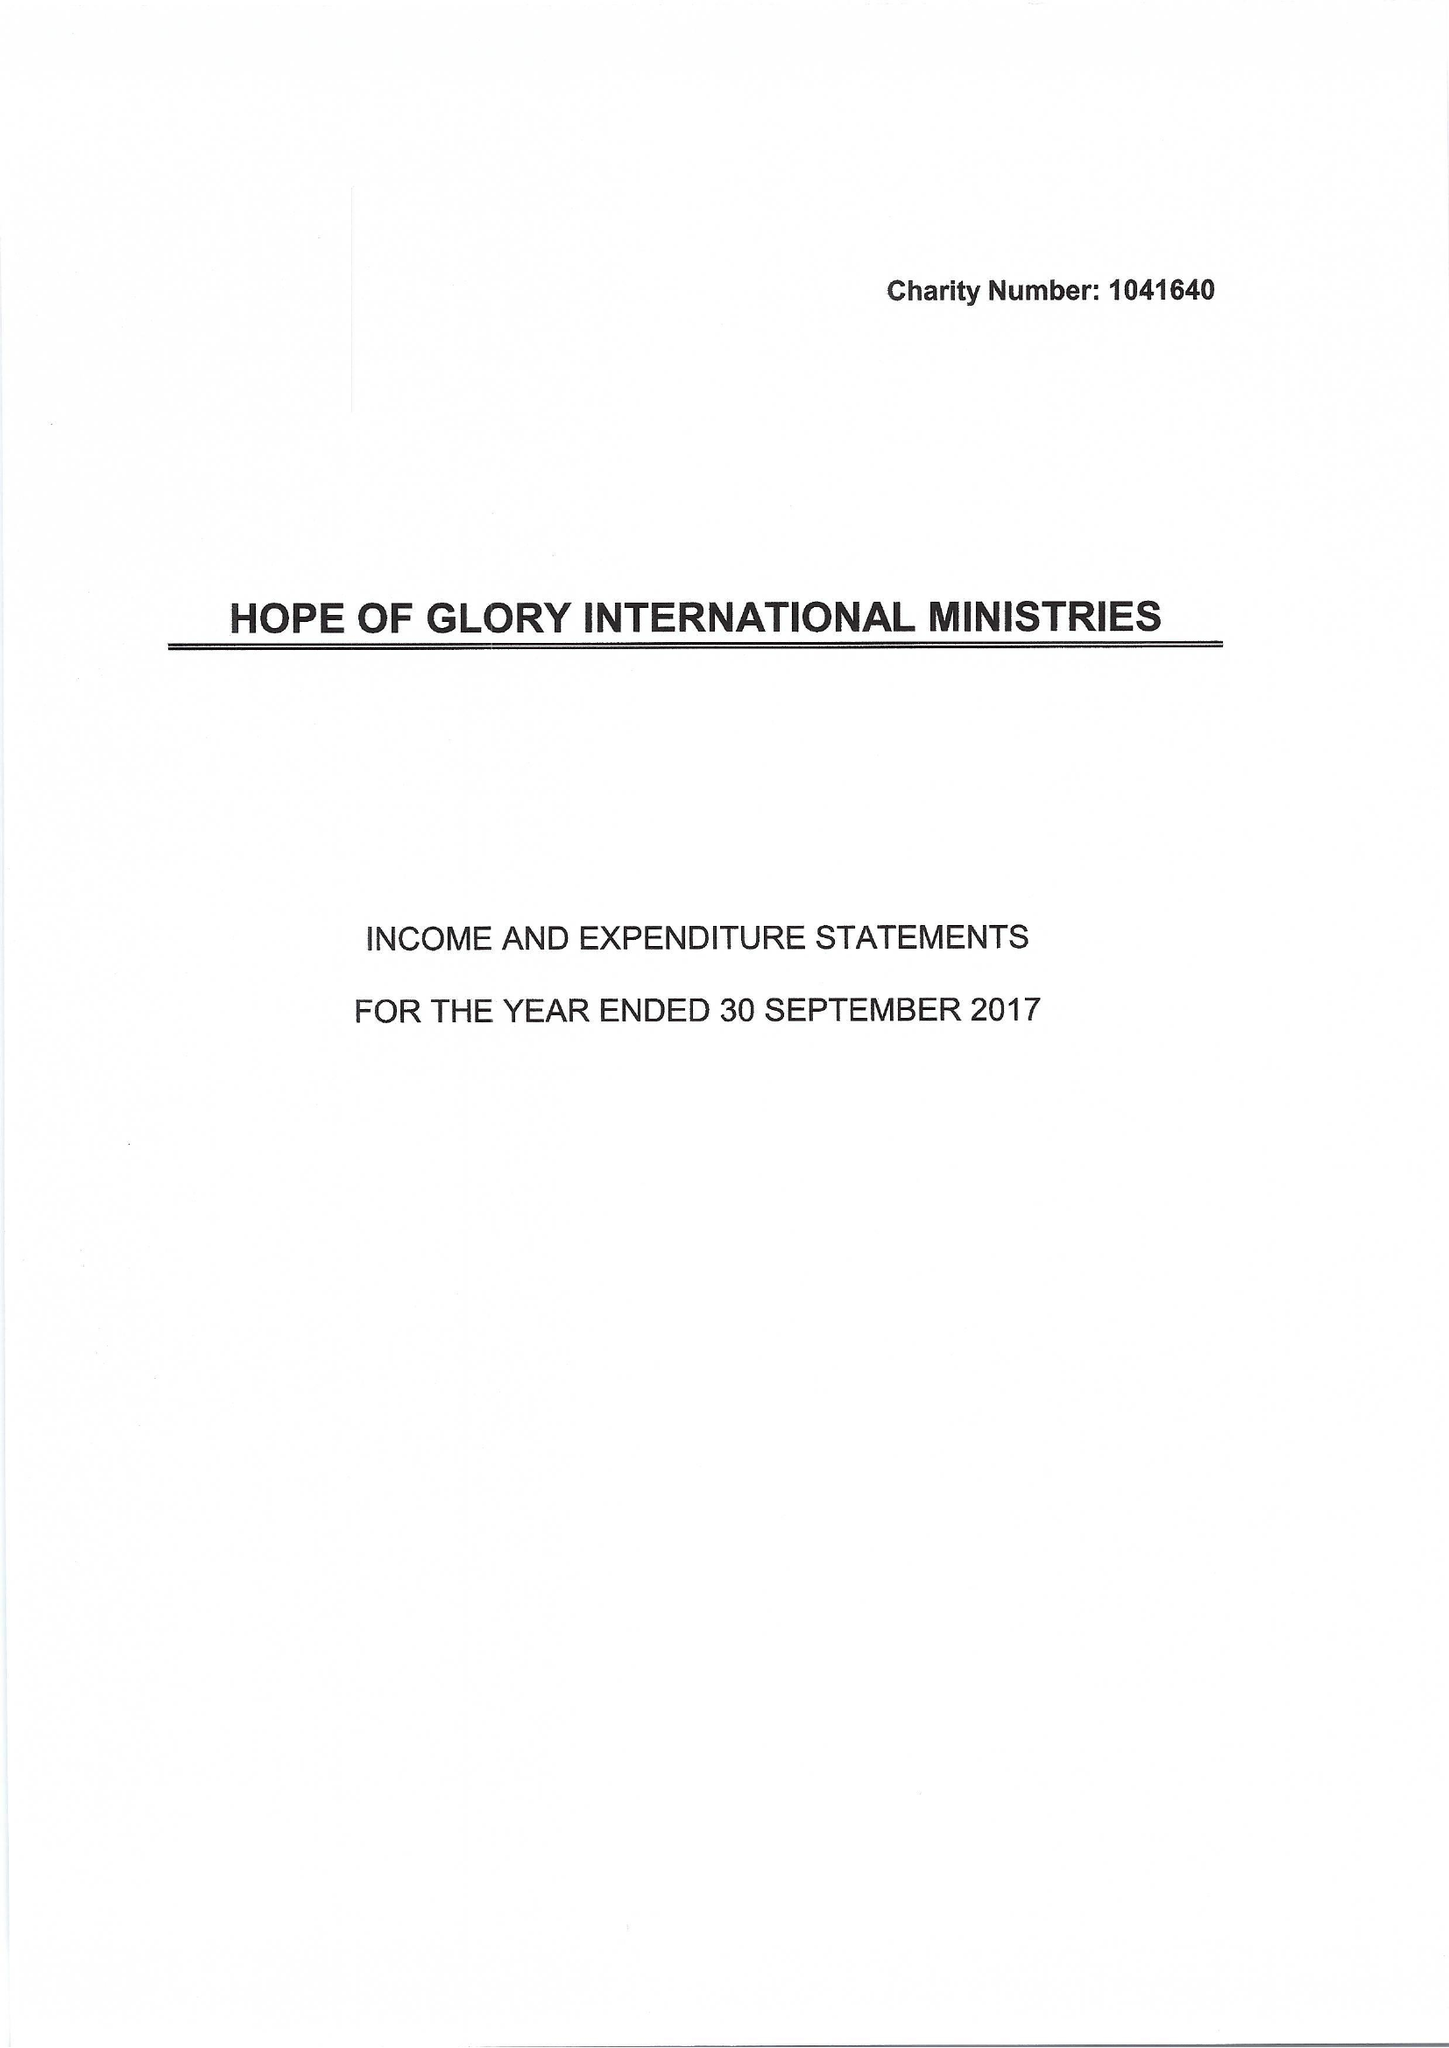What is the value for the spending_annually_in_british_pounds?
Answer the question using a single word or phrase. 97750.00 